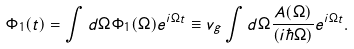<formula> <loc_0><loc_0><loc_500><loc_500>\Phi _ { 1 } ( t ) = \int d \Omega \Phi _ { 1 } ( \Omega ) e ^ { i \Omega t } \equiv v _ { g } \int d \Omega \frac { A ( \Omega ) } { ( i \hbar { \Omega } ) } e ^ { i \Omega t } .</formula> 